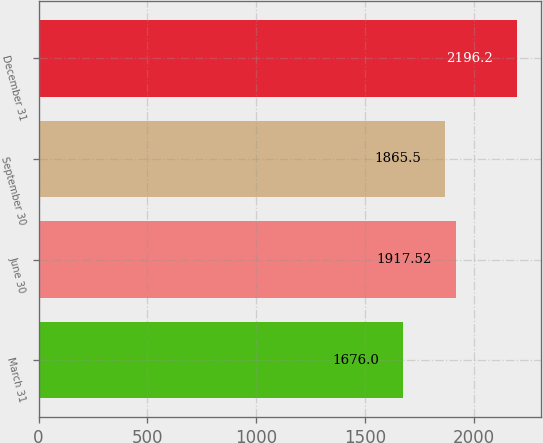Convert chart to OTSL. <chart><loc_0><loc_0><loc_500><loc_500><bar_chart><fcel>March 31<fcel>June 30<fcel>September 30<fcel>December 31<nl><fcel>1676<fcel>1917.52<fcel>1865.5<fcel>2196.2<nl></chart> 